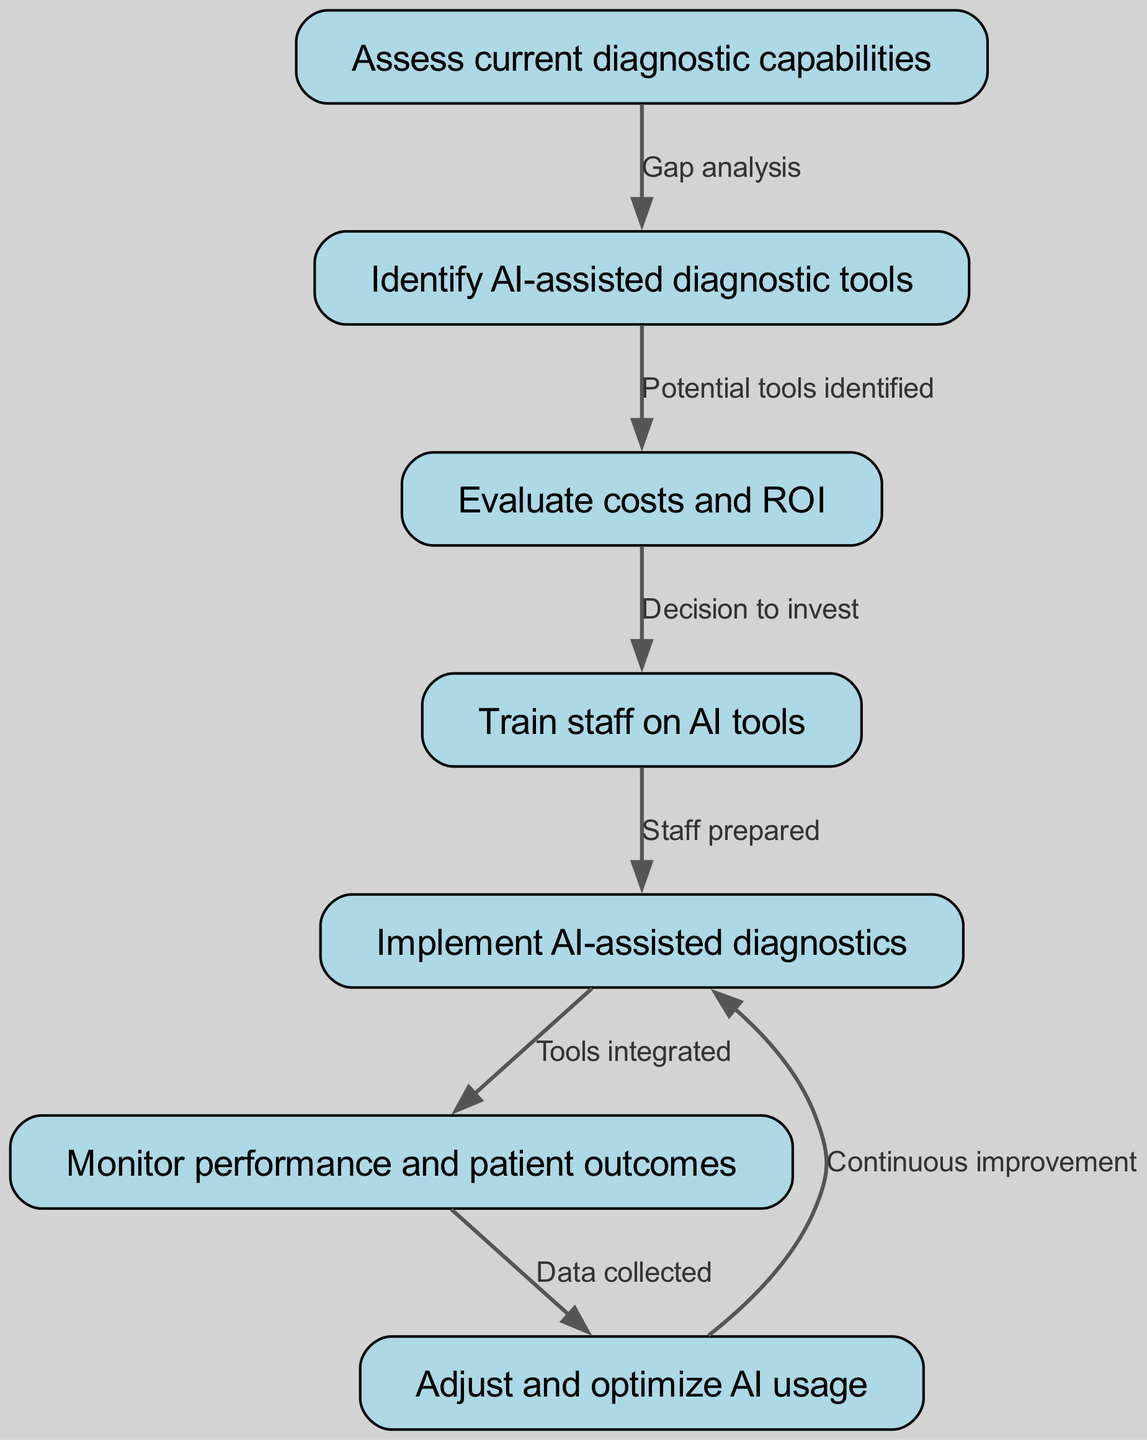What is the first step in the decision tree? The first step in the decision tree is to "Assess current diagnostic capabilities," which is represented by the first node in the diagram.
Answer: Assess current diagnostic capabilities How many nodes are in the diagram? By counting the distinct labeled steps in the diagram, we find there are seven nodes included.
Answer: 7 What is the last step after monitoring performance and patient outcomes? The last step after "Monitor performance and patient outcomes" is "Adjust and optimize AI usage," indicated as the next node flowing from the monitoring process.
Answer: Adjust and optimize AI usage What kind of relationship is there between assessing current diagnostic capabilities and identifying AI-assisted diagnostic tools? The relationship is labeled "Gap analysis," meaning the initial assessment reveals the need for identifying suitable AI-assisted tools, as represented by the directed edge connecting these two nodes.
Answer: Gap analysis What is the action taken after evaluating costs and ROI? After "Evaluate costs and ROI," the next action is to "Train staff on AI tools," which is the subsequent node connected in the flow of the decision-making process.
Answer: Train staff on AI tools Which node directly follows the implementation of AI-assisted diagnostics? The node that directly follows "Implement AI-assisted diagnostics" is "Monitor performance and patient outcomes," thereby ensuring the effectiveness of the implemented tools.
Answer: Monitor performance and patient outcomes What is the label of the edge connecting "Train staff on AI tools" to "Implement AI-assisted diagnostics"? The label of the edge connecting these two nodes is "Staff prepared," indicating readiness for implementation after training.
Answer: Staff prepared What is the purpose of the data collected during the monitoring phase? The purpose of the data collected during the "Monitor performance and patient outcomes" phase is to inform the next step, which is "Adjust and optimize AI usage," helping improve the system based on gathered insights.
Answer: Adjust and optimize AI usage 